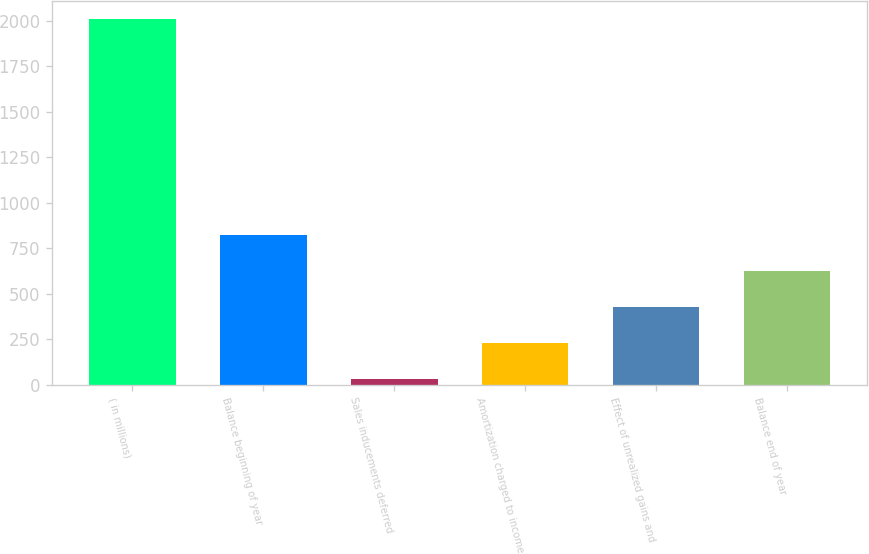<chart> <loc_0><loc_0><loc_500><loc_500><bar_chart><fcel>( in millions)<fcel>Balance beginning of year<fcel>Sales inducements deferred<fcel>Amortization charged to income<fcel>Effect of unrealized gains and<fcel>Balance end of year<nl><fcel>2009<fcel>820.4<fcel>28<fcel>226.1<fcel>424.2<fcel>622.3<nl></chart> 